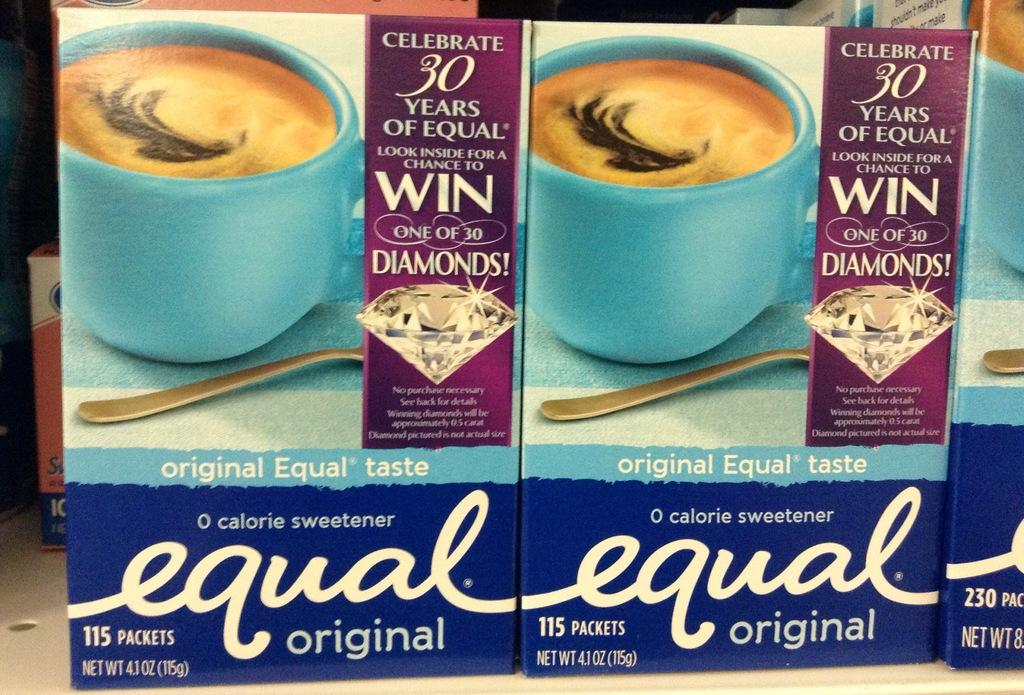What objects are present in the picture? There are boxes in the picture. What can be found on the surface of the boxes? The boxes have text on them. What image is depicted on the boxes? There is a picture of cups on the boxes. Can you hear the apple falling from the tree in the image? There is no apple or tree present in the image, so it is not possible to hear an apple falling. 